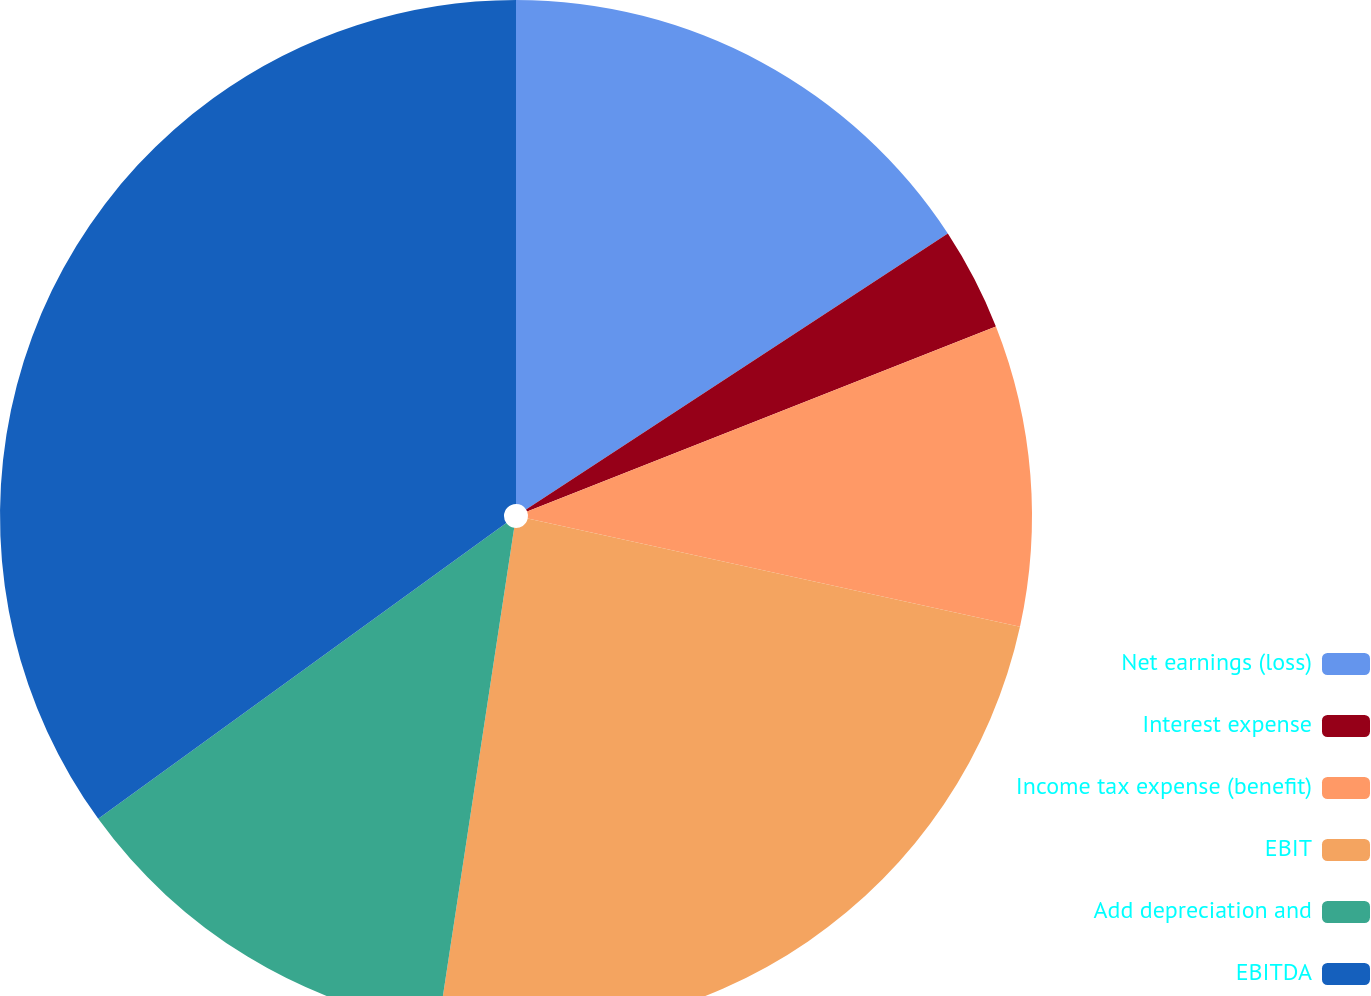<chart> <loc_0><loc_0><loc_500><loc_500><pie_chart><fcel>Net earnings (loss)<fcel>Interest expense<fcel>Income tax expense (benefit)<fcel>EBIT<fcel>Add depreciation and<fcel>EBITDA<nl><fcel>15.78%<fcel>3.23%<fcel>9.43%<fcel>23.96%<fcel>12.61%<fcel>34.98%<nl></chart> 